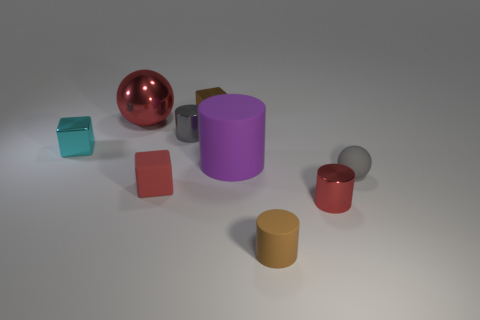Are there more metal cubes in front of the cyan cube than cyan shiny blocks?
Provide a short and direct response. No. What material is the big cylinder?
Your answer should be compact. Rubber. The purple object that is made of the same material as the brown cylinder is what shape?
Your response must be concise. Cylinder. There is a sphere that is on the right side of the tiny brown thing that is in front of the red cylinder; what is its size?
Ensure brevity in your answer.  Small. There is a cube behind the red metal sphere; what is its color?
Offer a very short reply. Brown. Is there another rubber thing of the same shape as the red matte thing?
Provide a succinct answer. No. Is the number of gray things to the right of the purple object less than the number of red matte cubes that are behind the small rubber ball?
Offer a terse response. No. What color is the rubber sphere?
Your answer should be compact. Gray. Is there a tiny brown cylinder behind the red metal object behind the big purple thing?
Give a very brief answer. No. What number of cyan cubes are the same size as the red rubber cube?
Offer a very short reply. 1. 